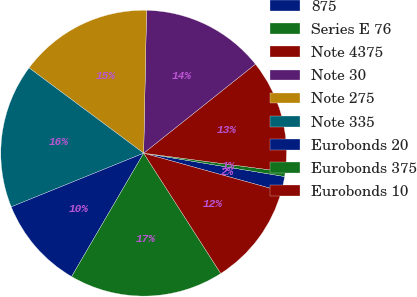Convert chart to OTSL. <chart><loc_0><loc_0><loc_500><loc_500><pie_chart><fcel>875<fcel>Series E 76<fcel>Note 4375<fcel>Note 30<fcel>Note 275<fcel>Note 335<fcel>Eurobonds 20<fcel>Eurobonds 375<fcel>Eurobonds 10<nl><fcel>1.69%<fcel>0.52%<fcel>12.8%<fcel>13.97%<fcel>15.14%<fcel>16.31%<fcel>10.46%<fcel>17.48%<fcel>11.63%<nl></chart> 